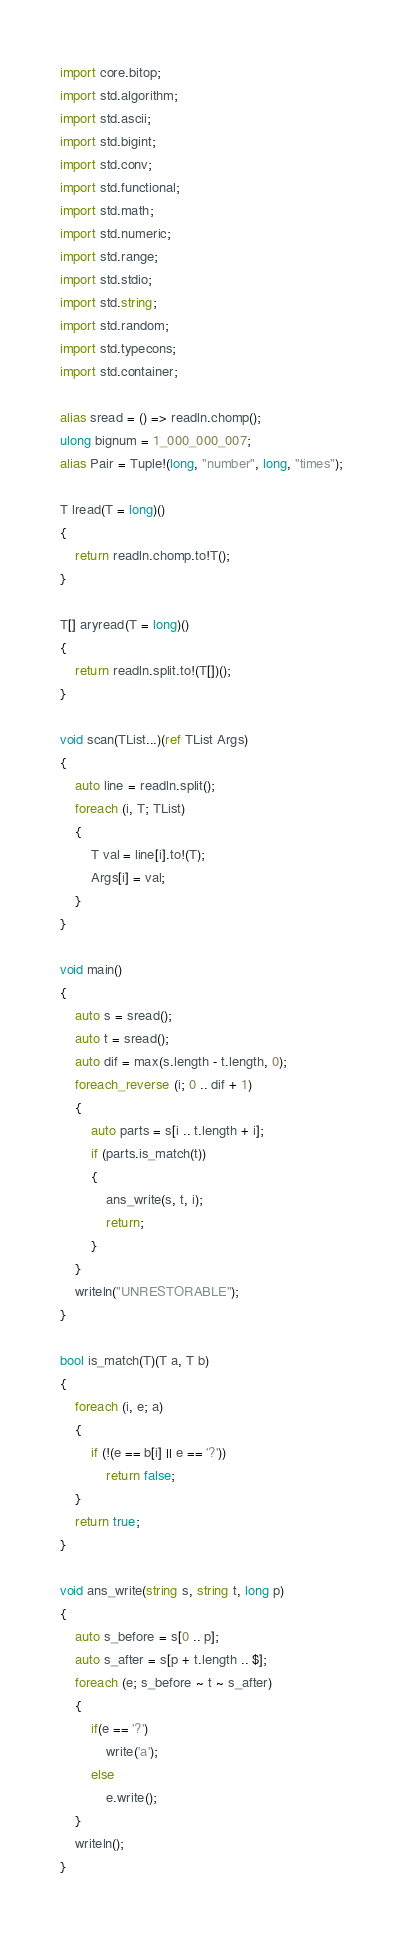<code> <loc_0><loc_0><loc_500><loc_500><_D_>import core.bitop;
import std.algorithm;
import std.ascii;
import std.bigint;
import std.conv;
import std.functional;
import std.math;
import std.numeric;
import std.range;
import std.stdio;
import std.string;
import std.random;
import std.typecons;
import std.container;

alias sread = () => readln.chomp();
ulong bignum = 1_000_000_007;
alias Pair = Tuple!(long, "number", long, "times");

T lread(T = long)()
{
    return readln.chomp.to!T();
}

T[] aryread(T = long)()
{
    return readln.split.to!(T[])();
}

void scan(TList...)(ref TList Args)
{
    auto line = readln.split();
    foreach (i, T; TList)
    {
        T val = line[i].to!(T);
        Args[i] = val;
    }
}

void main()
{
    auto s = sread();
    auto t = sread();
    auto dif = max(s.length - t.length, 0);
    foreach_reverse (i; 0 .. dif + 1)
    {
        auto parts = s[i .. t.length + i];
        if (parts.is_match(t))
        {
            ans_write(s, t, i);
            return;
        }
    }
    writeln("UNRESTORABLE");
}

bool is_match(T)(T a, T b)
{
    foreach (i, e; a)
    {
        if (!(e == b[i] || e == '?'))
            return false;
    }
    return true;
}

void ans_write(string s, string t, long p)
{
    auto s_before = s[0 .. p];
    auto s_after = s[p + t.length .. $];
    foreach (e; s_before ~ t ~ s_after)
    {
        if(e == '?')
            write('a');
        else
            e.write();
    }
    writeln();
}
</code> 